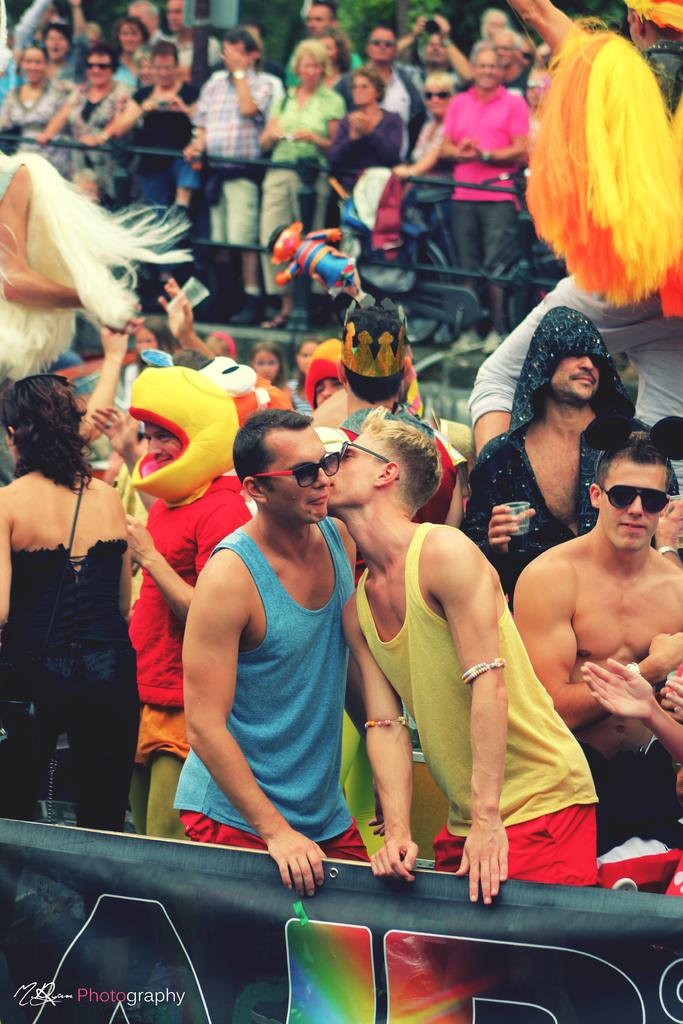What can be seen in the image? There are people standing in the image. What are the people wearing? The people are wearing clothes. What is at the bottom of the image? There is a banner at the bottom of the image. What type of brain is visible on the stove in the image? There is no brain or stove present in the image. How many baskets can be seen in the image? There are no baskets visible in the image; only people, clothes, and a banner are present. 